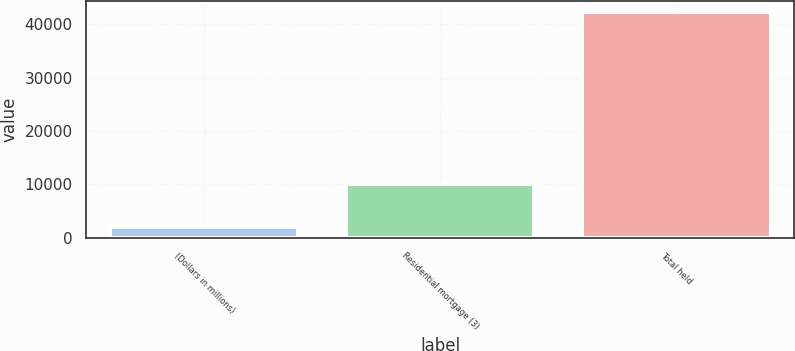Convert chart. <chart><loc_0><loc_0><loc_500><loc_500><bar_chart><fcel>(Dollars in millions)<fcel>Residential mortgage (3)<fcel>Total held<nl><fcel>2008<fcel>10013<fcel>42209<nl></chart> 